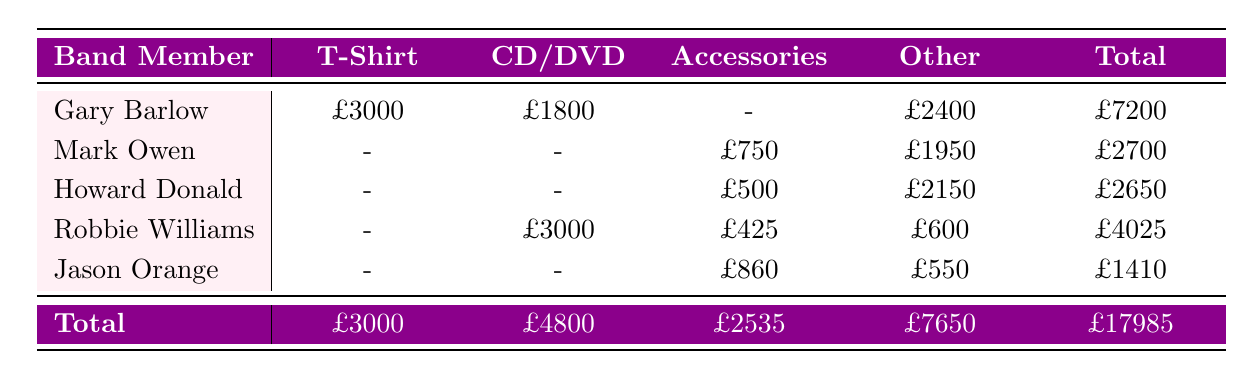What was the total revenue generated by Gary Barlow's merchandise? Looking at Gary Barlow's row, the total revenue from his merchandise is listed as £7200.
Answer: £7200 Which band member sold more in Accessories, Jason Orange or Howard Donald? Jason Orange's Accessories revenue is £860 while Howard Donald's is £500. Therefore, Jason Orange sold more in the Accessories category.
Answer: Jason Orange Did Robbie Williams have any sales in the T-Shirt category? According to the table, Robbie Williams does not have any sales listed in the T-Shirt category as it shows a value of "-".
Answer: No What is the total revenue for all band members combined from CD/DVD sales? The total revenue for CD/DVD sales can be found by adding the values: Gary Barlow (£1800) + Robbie Williams (£3000) = £4800. Hence the overall total for CD/DVD is £4800.
Answer: £4800 What is the difference in total revenue between the band member with the highest total revenue and the one with the lowest? The highest total revenue is £7200 (Gary Barlow) and the lowest is £1410 (Jason Orange). The difference is £7200 - £1410 = £5790.
Answer: £5790 Which product category generated the least revenue overall? By reviewing the totals for each category: T-Shirt (£3000) + CD/DVD (£4800) + Accessories (£2535) + Other (£7650), Accessories has the least revenue at £2535.
Answer: Accessories Did Mark Owen sell any T-Shirts? The table indicates that Mark Owen's T-Shirt revenue is listed as "-", which means he did not sell any.
Answer: No What was the total revenue generated from "Other" merchandise? The "Other" merchandise revenue is calculated by adding up: Gary Barlow (£2400) + Mark Owen (£1950) + Howard Donald (£2150) + Robbie Williams (£600) + Jason Orange (£550) = £7650.
Answer: £7650 